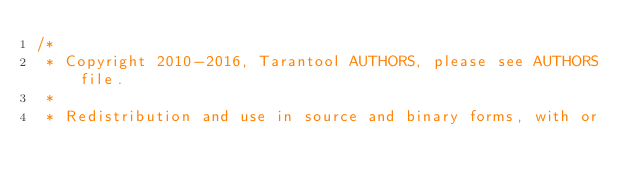<code> <loc_0><loc_0><loc_500><loc_500><_C_>/*
 * Copyright 2010-2016, Tarantool AUTHORS, please see AUTHORS file.
 *
 * Redistribution and use in source and binary forms, with or</code> 